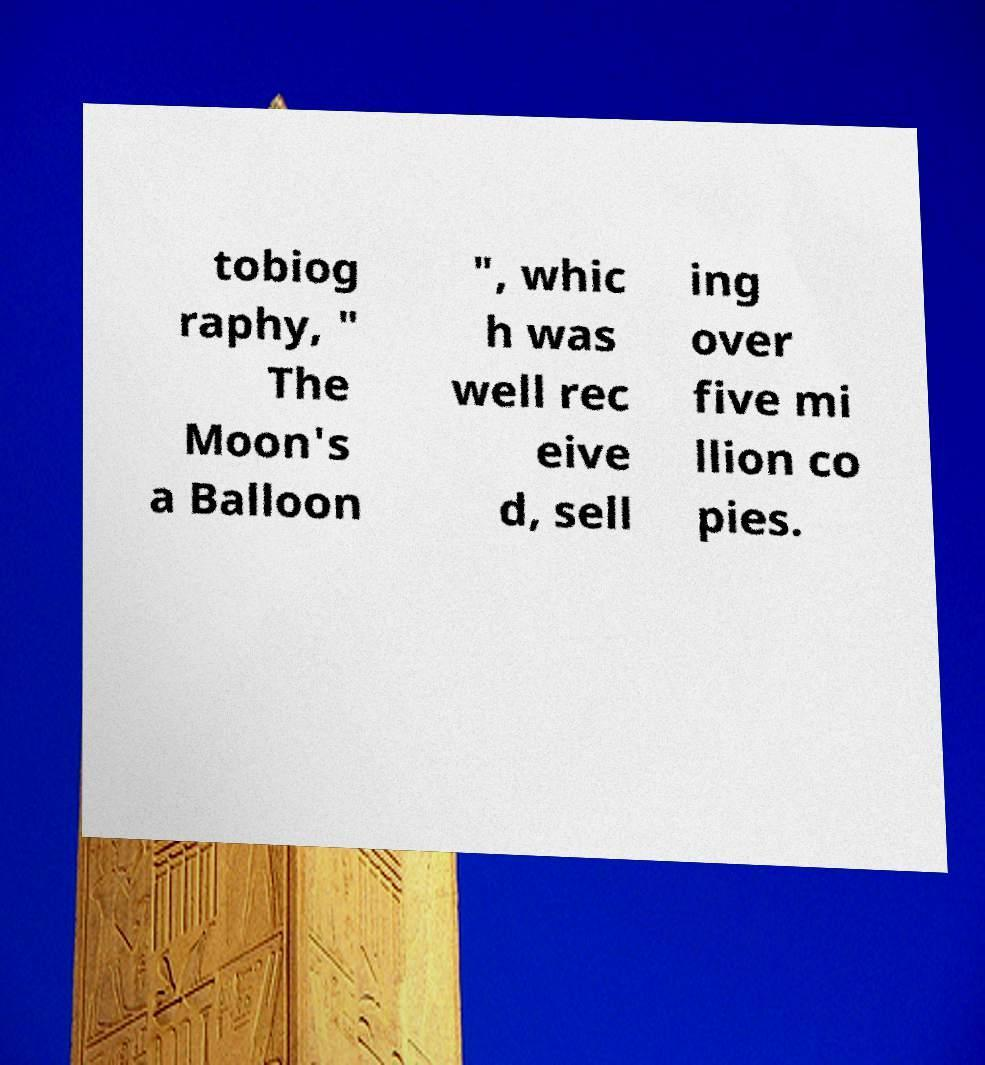For documentation purposes, I need the text within this image transcribed. Could you provide that? tobiog raphy, " The Moon's a Balloon ", whic h was well rec eive d, sell ing over five mi llion co pies. 